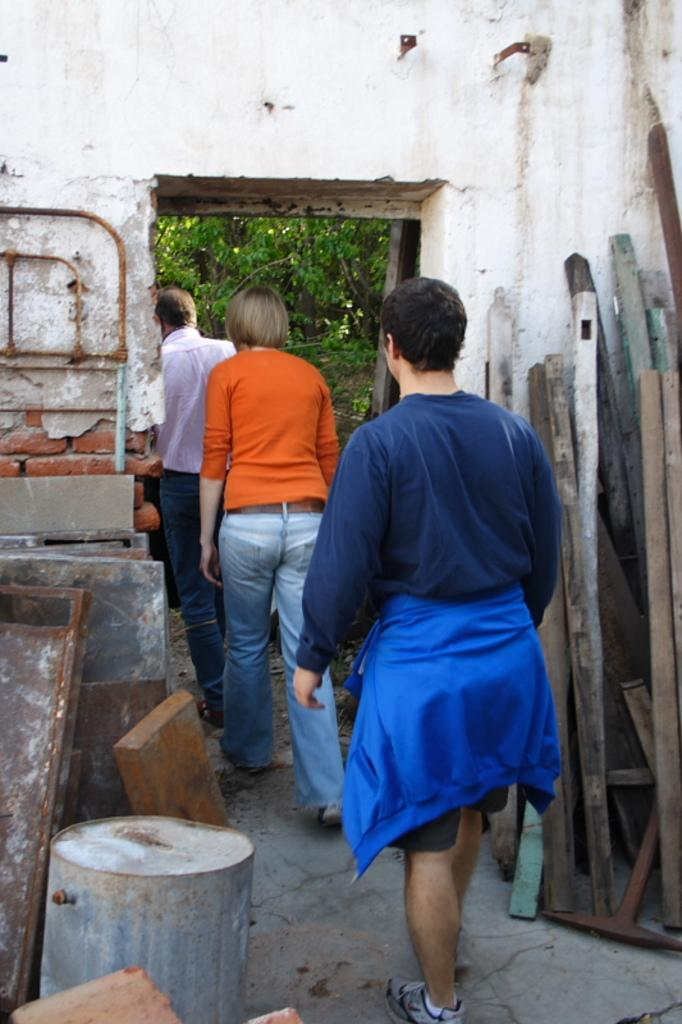Who or what can be seen in the image? There are people in the image. What can be seen in the background of the image? In the background, there are rods, logs, cardboards, an object, trees, and a wall. Can you describe the object in the background? Unfortunately, the facts provided do not give enough information to describe the object in the background. What type of vegetation is visible in the background? Trees are visible in the background of the image. What type of nut can be seen falling from the tree in the image? There is no nut falling from a tree in the image. Can you describe the mist surrounding the people in the image? There is no mist present in the image. 